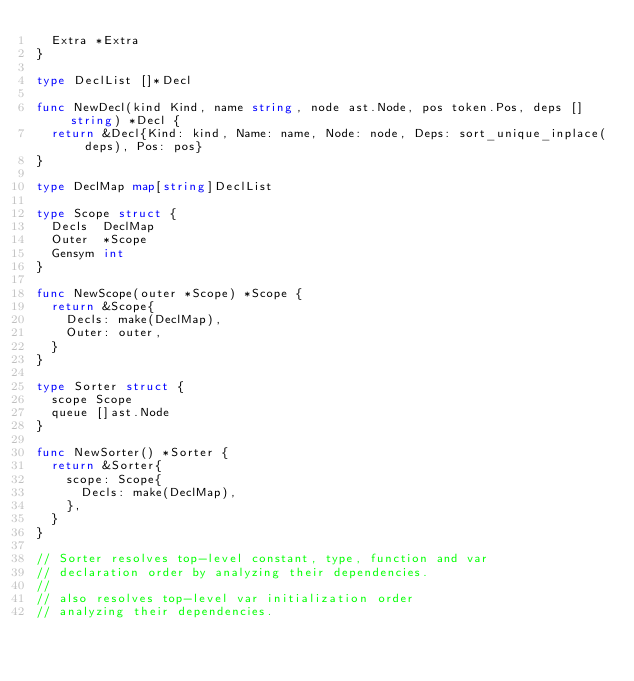<code> <loc_0><loc_0><loc_500><loc_500><_Go_>	Extra *Extra
}

type DeclList []*Decl

func NewDecl(kind Kind, name string, node ast.Node, pos token.Pos, deps []string) *Decl {
	return &Decl{Kind: kind, Name: name, Node: node, Deps: sort_unique_inplace(deps), Pos: pos}
}

type DeclMap map[string]DeclList

type Scope struct {
	Decls  DeclMap
	Outer  *Scope
	Gensym int
}

func NewScope(outer *Scope) *Scope {
	return &Scope{
		Decls: make(DeclMap),
		Outer: outer,
	}
}

type Sorter struct {
	scope Scope
	queue []ast.Node
}

func NewSorter() *Sorter {
	return &Sorter{
		scope: Scope{
			Decls: make(DeclMap),
		},
	}
}

// Sorter resolves top-level constant, type, function and var
// declaration order by analyzing their dependencies.
//
// also resolves top-level var initialization order
// analyzing their dependencies.
</code> 